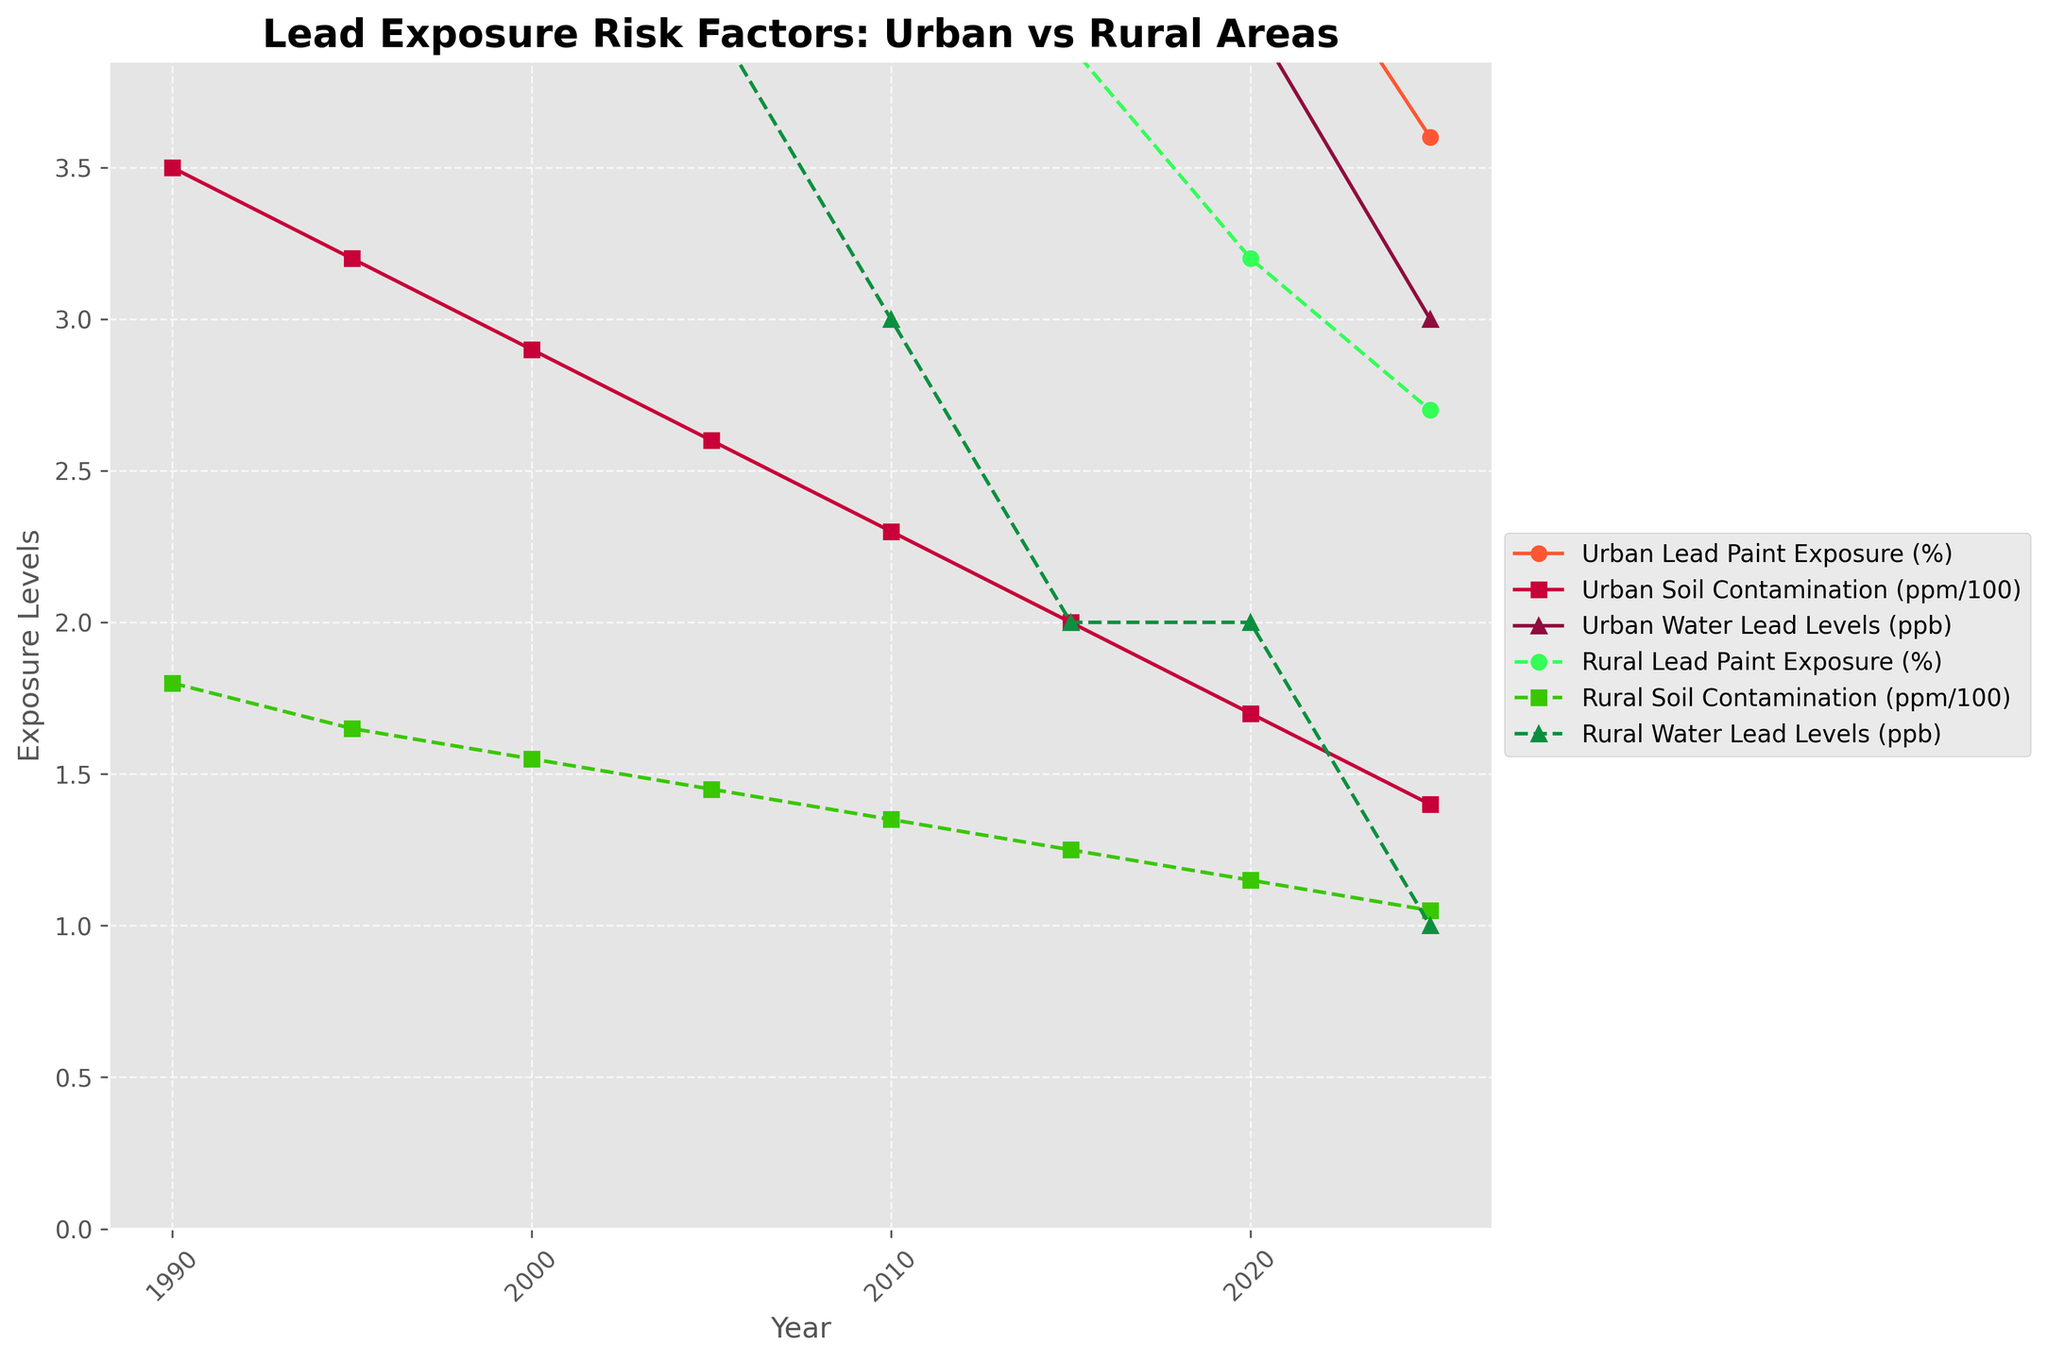What is the trend of urban lead paint exposure from 1990 to 2025? The figure shows that urban lead paint exposure consistently decreases over time, starting from 15.2% in 1990 and dropping to 3.6% in 2025
Answer: Decreasing Which year shows the highest urban soil contamination, and what is its value? Looking at the urban soil contamination line, it is highest in 1990 with the value of 350 ppm
Answer: 1990, 350 ppm How does rural lead paint exposure in 2025 compare to urban lead paint exposure in 2025? At 2025, rural lead paint exposure is 2.7% while urban lead paint exposure is 3.6%, so rural is lower than urban
Answer: Rural is lower Which area has consistently higher water lead levels, urban or rural? The urban water lead levels line is consistently higher than the rural water lead levels line throughout the years
Answer: Urban What is the difference in urban lead water levels between 1995 and 2005? Urban water lead levels in 1995 are 10 ppb and in 2005 are 7 ppb, so the difference is 10 - 7
Answer: 3 ppb Between 1990 and 2025, which has decreased more significantly: urban soil contamination or rural soil contamination? Urban soil contamination decreased from 350 ppm to 140 ppm and rural from 180 ppm to 105 ppm. Calculation follows: urban - 350 - 140 = 210 ppm, rural - 180 - 105 = 75 ppm; hence urban has decreased more significantly
Answer: Urban soil contamination What percentage of urban lead paint exposure was reduced from 1990 to 2020? Urban lead paint exposure was 15.2% in 1990 and decreased to 4.5% in 2020. Thus, the reduction is 15.2% - 4.5% = 10.7%
Answer: 10.7% In what years do both urban and rural water lead levels reach their lowest points, and what are those levels? The lines for urban water lead levels and rural water lead levels both reach their lowest levels in 2025, at 3 ppb for urban and 1 ppb for rural
Answer: 2025, 3 ppb and 1 ppb What is the difference in rural soil contamination between 2000 and 2015? In 2000, rural soil contamination is 155 ppm and in 2015 it is 125 ppm, so the difference is 155 - 125
Answer: 30 ppm 